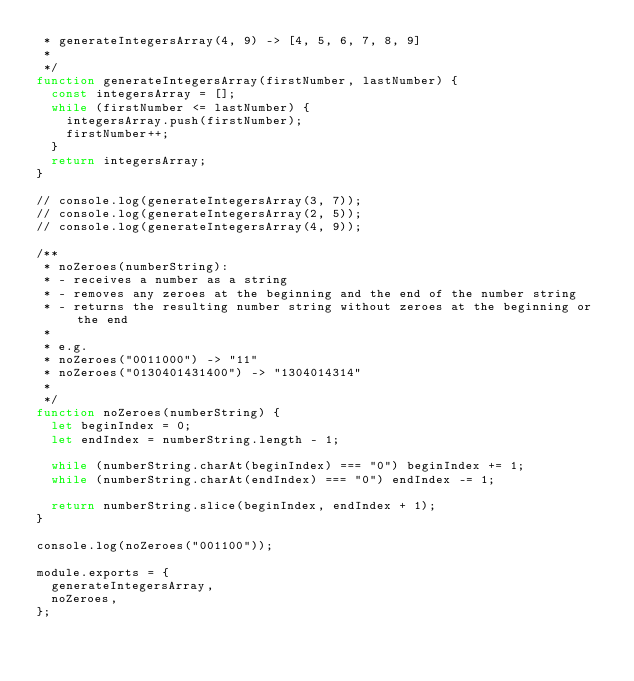Convert code to text. <code><loc_0><loc_0><loc_500><loc_500><_JavaScript_> * generateIntegersArray(4, 9) -> [4, 5, 6, 7, 8, 9]
 *
 */
function generateIntegersArray(firstNumber, lastNumber) {
  const integersArray = [];
  while (firstNumber <= lastNumber) {
    integersArray.push(firstNumber);
    firstNumber++;
  }
  return integersArray;
}

// console.log(generateIntegersArray(3, 7));
// console.log(generateIntegersArray(2, 5));
// console.log(generateIntegersArray(4, 9));

/**
 * noZeroes(numberString):
 * - receives a number as a string
 * - removes any zeroes at the beginning and the end of the number string
 * - returns the resulting number string without zeroes at the beginning or the end
 *
 * e.g.
 * noZeroes("0011000") -> "11"
 * noZeroes("0130401431400") -> "1304014314"
 *
 */
function noZeroes(numberString) {
  let beginIndex = 0;
  let endIndex = numberString.length - 1;

  while (numberString.charAt(beginIndex) === "0") beginIndex += 1;
  while (numberString.charAt(endIndex) === "0") endIndex -= 1;

  return numberString.slice(beginIndex, endIndex + 1);
}

console.log(noZeroes("001100"));

module.exports = {
  generateIntegersArray,
  noZeroes,
};
</code> 